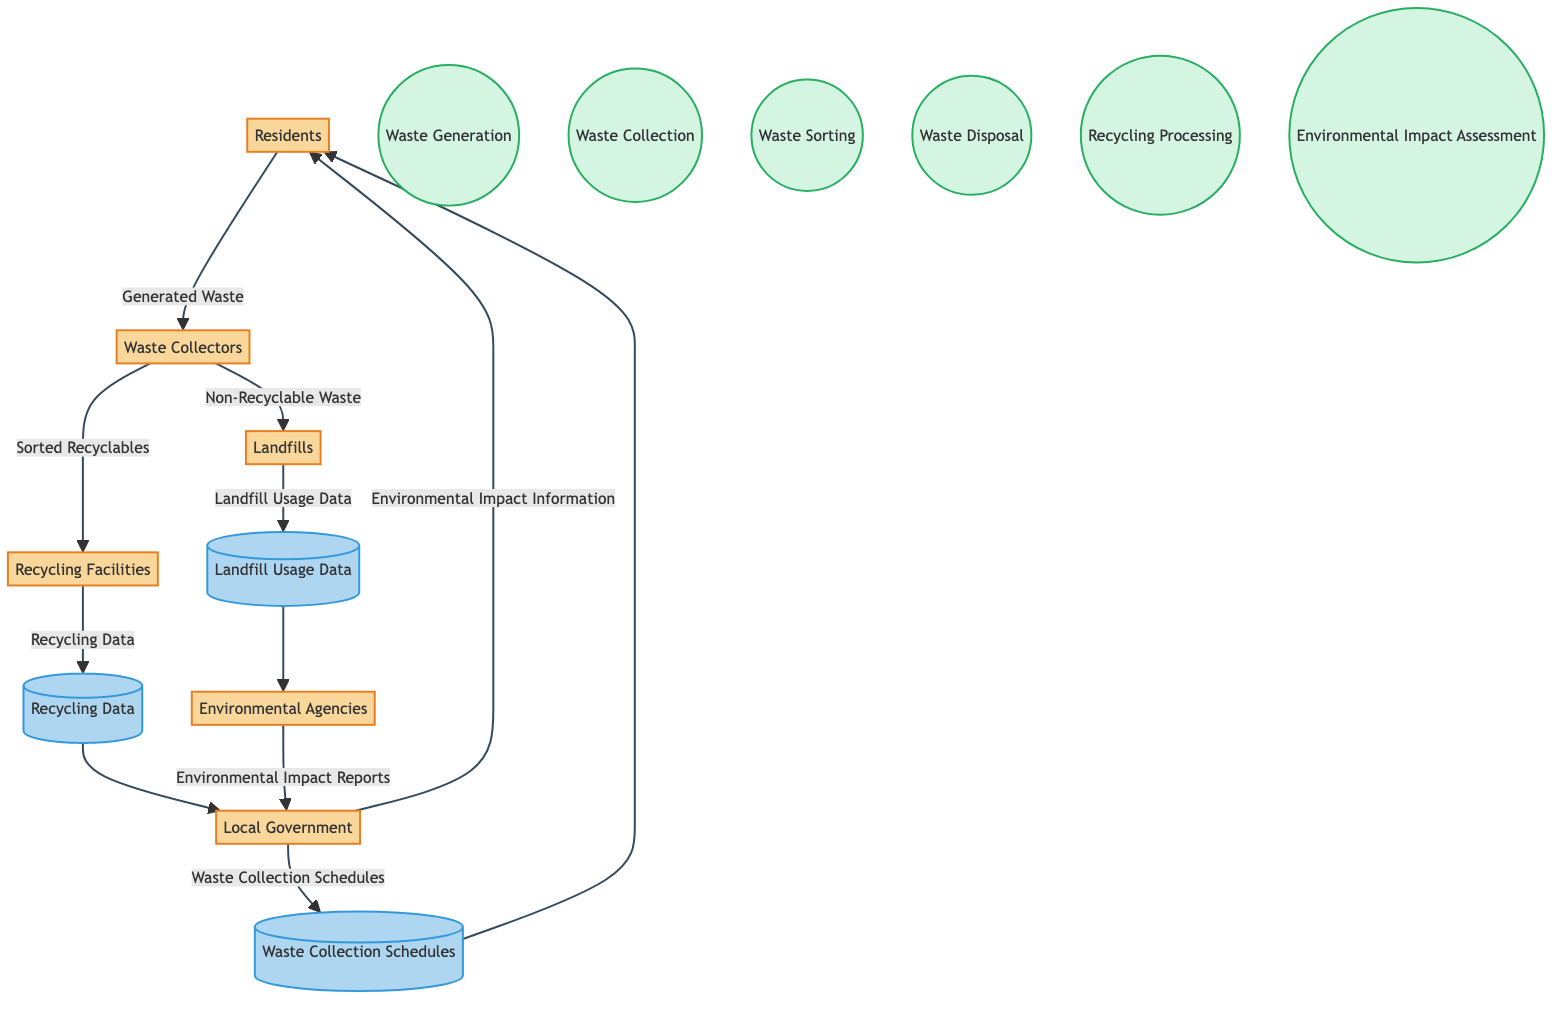What are the entities involved in the waste management process? The diagram includes six entities: Residents, Waste Collectors, Recycling Facilities, Landfills, Local Government, and Environmental Agencies.
Answer: Residents, Waste Collectors, Recycling Facilities, Landfills, Local Government, Environmental Agencies How many processes are depicted in the diagram? There are six processes shown in the diagram: Waste Generation, Waste Collection, Waste Sorting, Waste Disposal, Recycling Processing, and Environmental Impact Assessment.
Answer: Six What flows from Waste Collectors to Recycling Facilities? The data flow from Waste Collectors to Recycling Facilities is "Sorted Recyclables," which indicates the materials that have been separated for recycling.
Answer: Sorted Recyclables Which entity receives Environmental Impact Reports? Environmental Agencies send Environmental Impact Reports to the Local Government, indicating that the government is accountable for environmental oversight based on these assessments.
Answer: Local Government What is the data that Waste Collectors send to Landfills? Waste Collectors send "Non-Recyclable Waste" to Landfills, which refers to waste that cannot be processed for recycling.
Answer: Non-Recyclable Waste What type of data is contained in the data store titled "Recycling Data"? The Recycling Data store holds information on the amount and type of waste that is recycled, indicating the efficiency and volume of recycling efforts within the community.
Answer: Amount and type of waste recycled What connects Landfills to Environmental Agencies? The data flow connecting Landfills to Environmental Agencies is "Landfill Usage Data," which tracks the volume of waste deposited at the landfill and informs agencies about waste management practices.
Answer: Landfill Usage Data What does the Local Government provide to Residents? The Local Government supplies "Waste Collection Schedules" to Residents, which informs them of the timings for waste pickups in the community.
Answer: Waste Collection Schedules How many data stores are represented in the diagram? There are three data stores shown in the diagram: Recycling Data, Waste Collection Schedules, and Landfill Usage Data, reflecting the various information systems utilized in waste management.
Answer: Three 